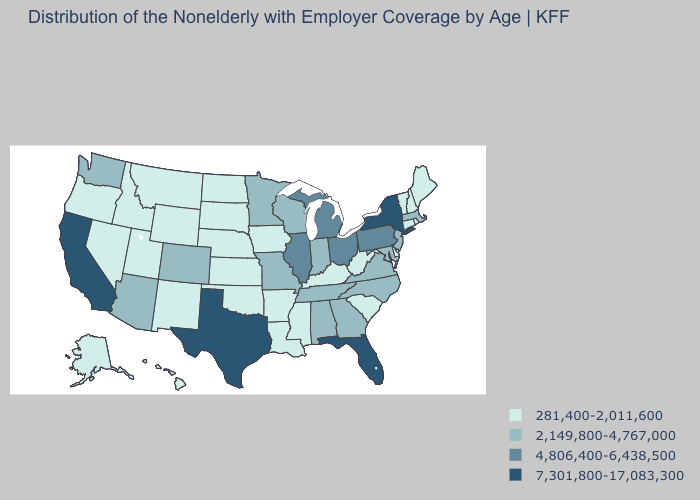Does Arizona have the highest value in the West?
Write a very short answer. No. Which states have the highest value in the USA?
Keep it brief. California, Florida, New York, Texas. Among the states that border Virginia , which have the lowest value?
Write a very short answer. Kentucky, West Virginia. Name the states that have a value in the range 4,806,400-6,438,500?
Short answer required. Illinois, Michigan, Ohio, Pennsylvania. Among the states that border Ohio , which have the lowest value?
Concise answer only. Kentucky, West Virginia. What is the value of Tennessee?
Keep it brief. 2,149,800-4,767,000. What is the highest value in the South ?
Answer briefly. 7,301,800-17,083,300. What is the value of Ohio?
Short answer required. 4,806,400-6,438,500. Name the states that have a value in the range 4,806,400-6,438,500?
Be succinct. Illinois, Michigan, Ohio, Pennsylvania. Name the states that have a value in the range 281,400-2,011,600?
Be succinct. Alaska, Arkansas, Connecticut, Delaware, Hawaii, Idaho, Iowa, Kansas, Kentucky, Louisiana, Maine, Mississippi, Montana, Nebraska, Nevada, New Hampshire, New Mexico, North Dakota, Oklahoma, Oregon, Rhode Island, South Carolina, South Dakota, Utah, Vermont, West Virginia, Wyoming. Name the states that have a value in the range 4,806,400-6,438,500?
Keep it brief. Illinois, Michigan, Ohio, Pennsylvania. Does Arkansas have the highest value in the USA?
Short answer required. No. Among the states that border Michigan , which have the lowest value?
Be succinct. Indiana, Wisconsin. What is the value of Wisconsin?
Give a very brief answer. 2,149,800-4,767,000. Which states have the lowest value in the MidWest?
Answer briefly. Iowa, Kansas, Nebraska, North Dakota, South Dakota. 